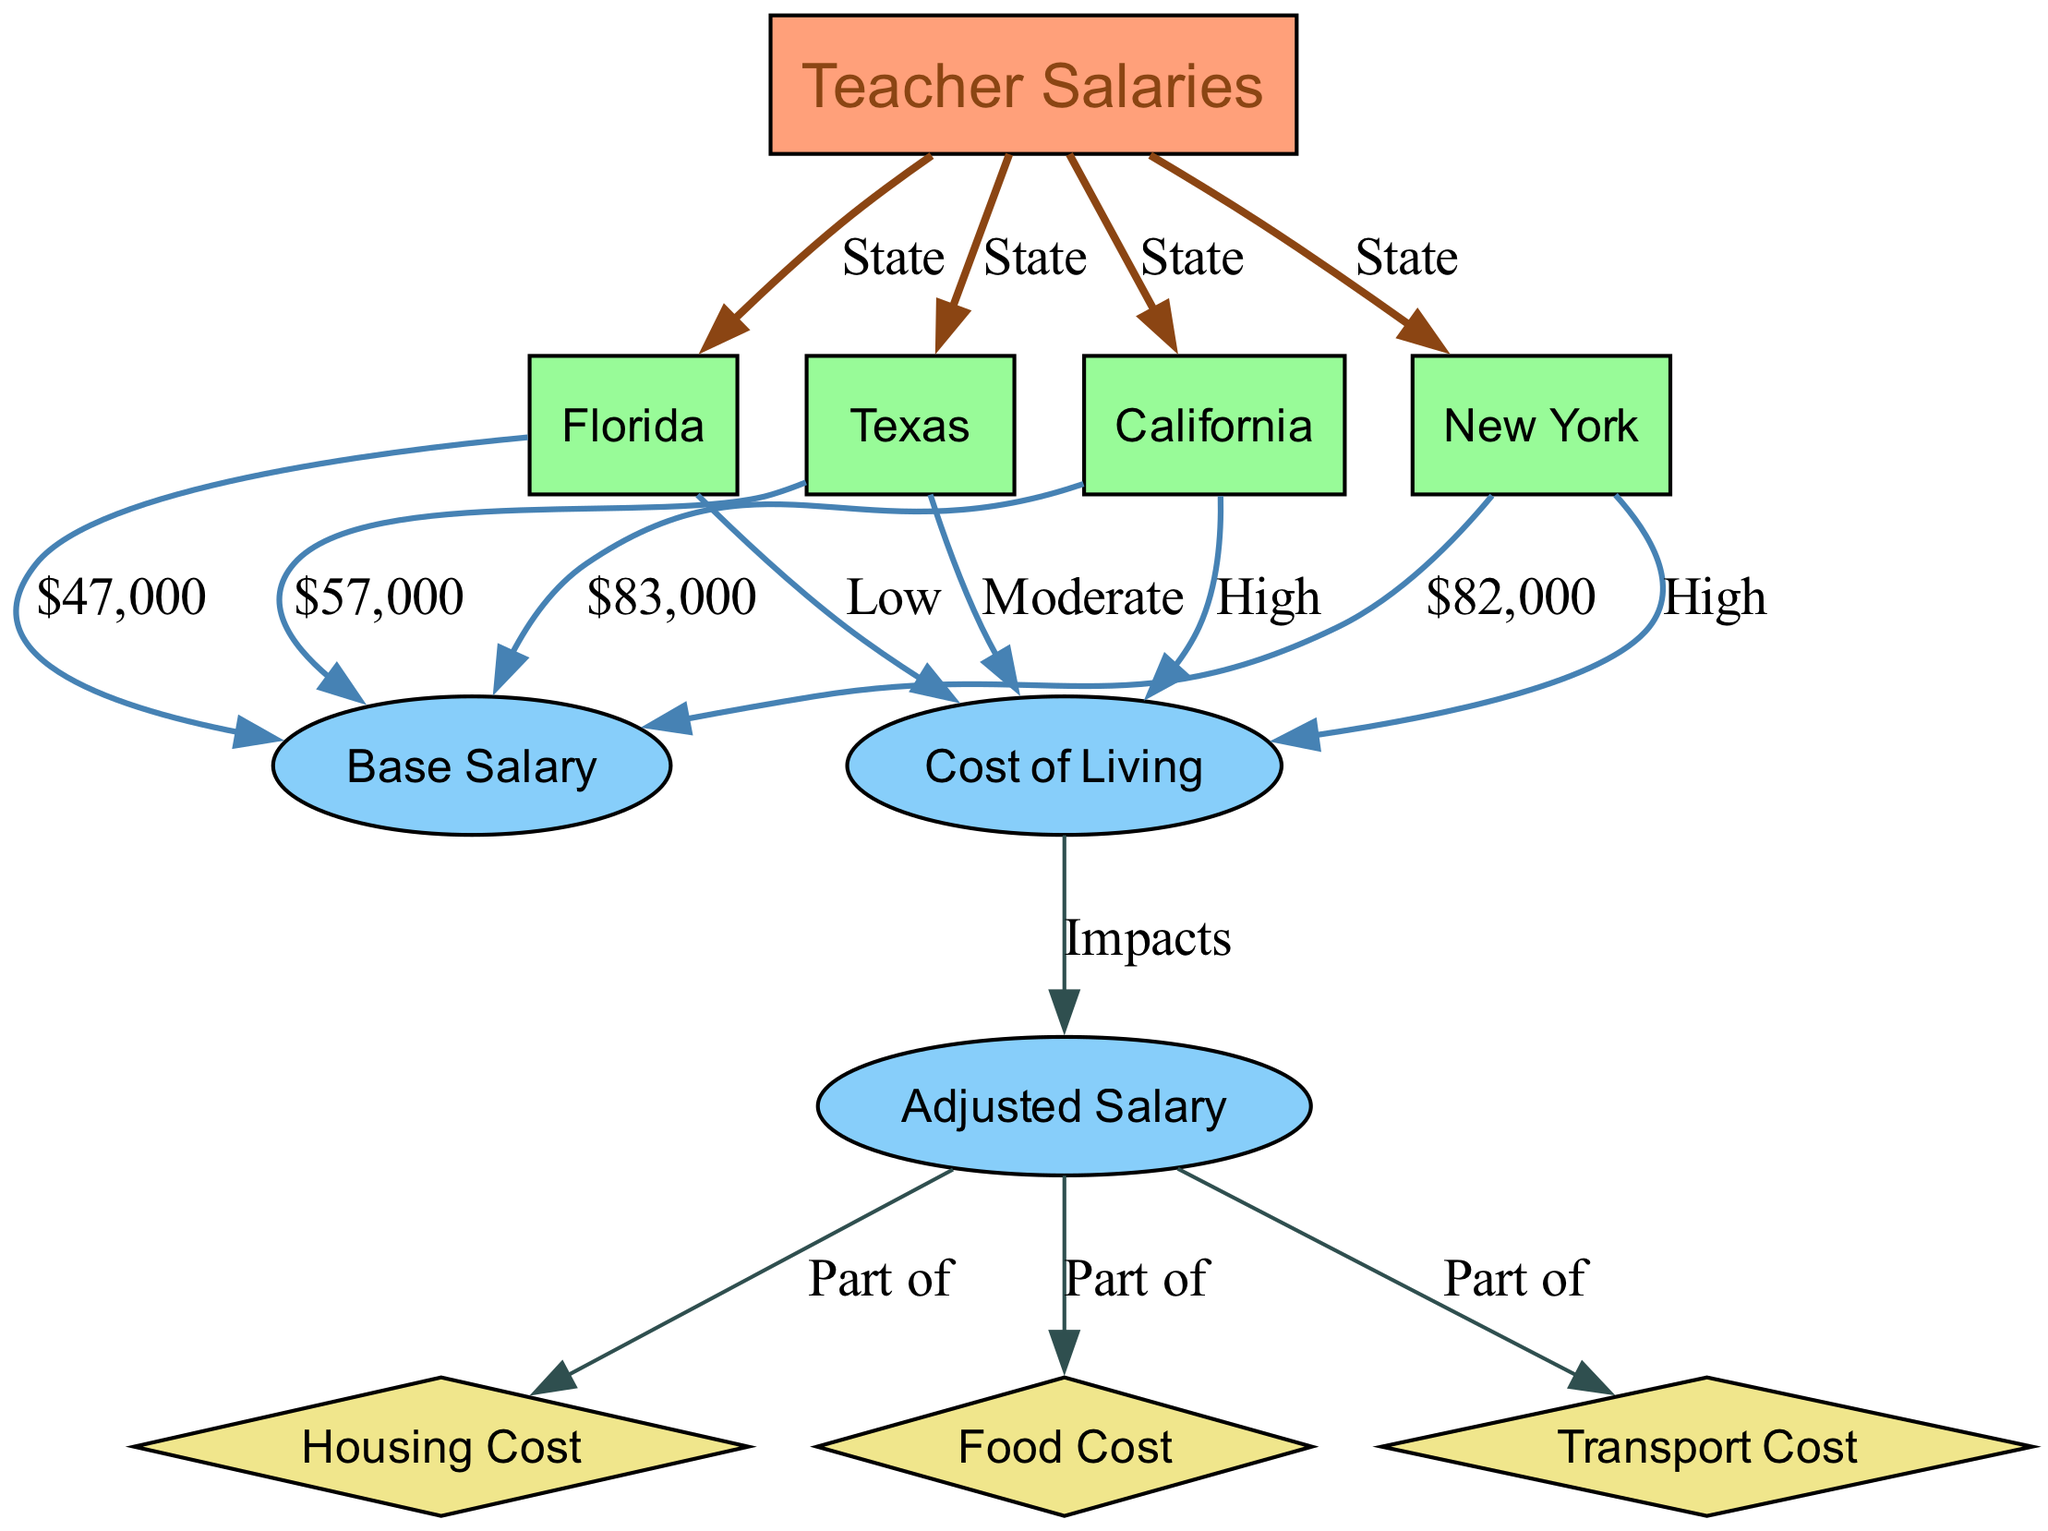What is the base salary for teachers in California? The diagram specifies a direct edge from California to Base Salary, with a label indicating the value. Examining the diagram shows that California's Base Salary is $83,000.
Answer: $83,000 Which state has the lowest base salary for teachers? By looking at the base salaries listed in the diagram for each state, Florida has the lowest value at $47,000 compared to California, Texas, and New York.
Answer: Florida How many states are represented in the diagram? The diagram includes four states connected to Teacher Salaries: California, Texas, Florida, and New York. Therefore, the number of states represented is four.
Answer: Four What is the cost of living in Texas? Referring to the edge connecting Texas to Cost of Living, the label indicates that the cost of living in Texas is categorized as Moderate.
Answer: Moderate Which two costs are parts of the adjusted salary? The edges indicate that both Housing Cost and Food Cost are represented as parts of the Adjusted Salary. Together, they are directly linked to the Adjusted Salary node.
Answer: Housing Cost and Food Cost What type of relationship connects Cost of Living and Adjusted Salary? The diagram shows an edge from Cost of Living to Adjusted Salary, labeled as "Impacts." This indicates that there is a direct impact relationship between them.
Answer: Impacts What is the base salary for teachers in New York? The diagram directly shows that New York has a Base Salary of $82,000 as indicated by the corresponding edge to the Base Salary node.
Answer: $82,000 Between the states listed, which one has a high cost of living? The diagram shows that both California and New York are labeled as having a High cost of living, indicated by their connections to the Cost of Living node.
Answer: California and New York What part of the adjusted salary does transport cost represent? The diagram indicates an edge connecting Adjusted Salary to Transport Cost, labeled as "Part of," showing that Transport Cost is one of the components of Adjusted Salary.
Answer: Part of 